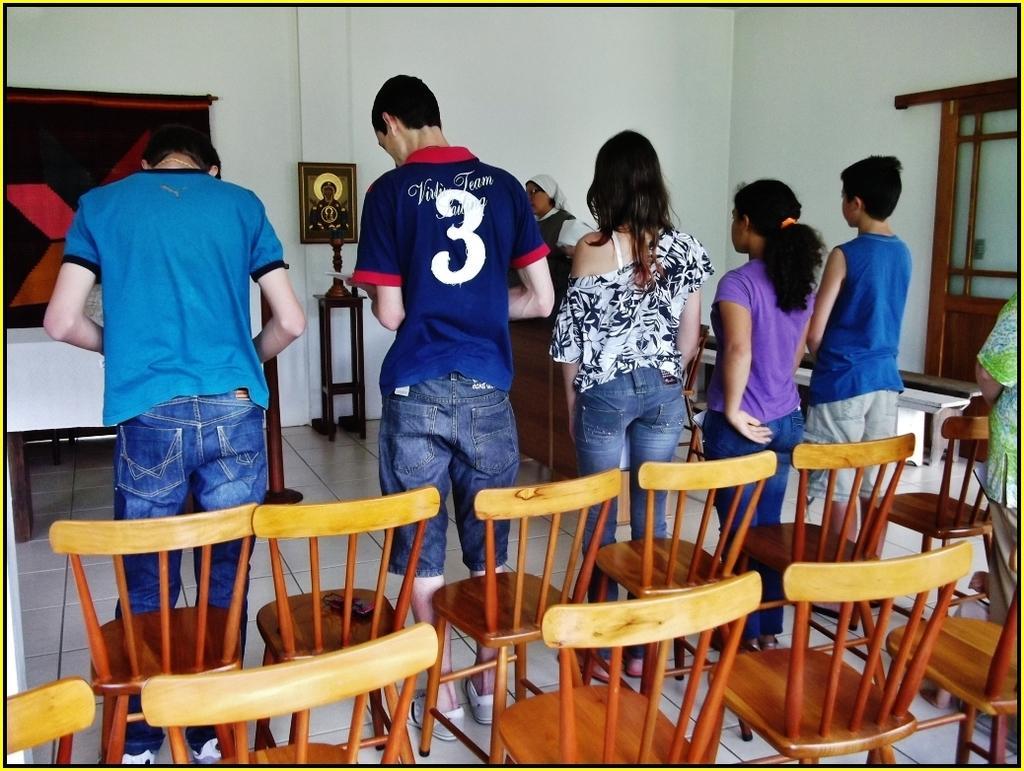How would you summarize this image in a sentence or two? In the center we can see few persons were standing. In the front bottom, we can see few empty chairs. In the background there is a wall,photo frame,window and table. 